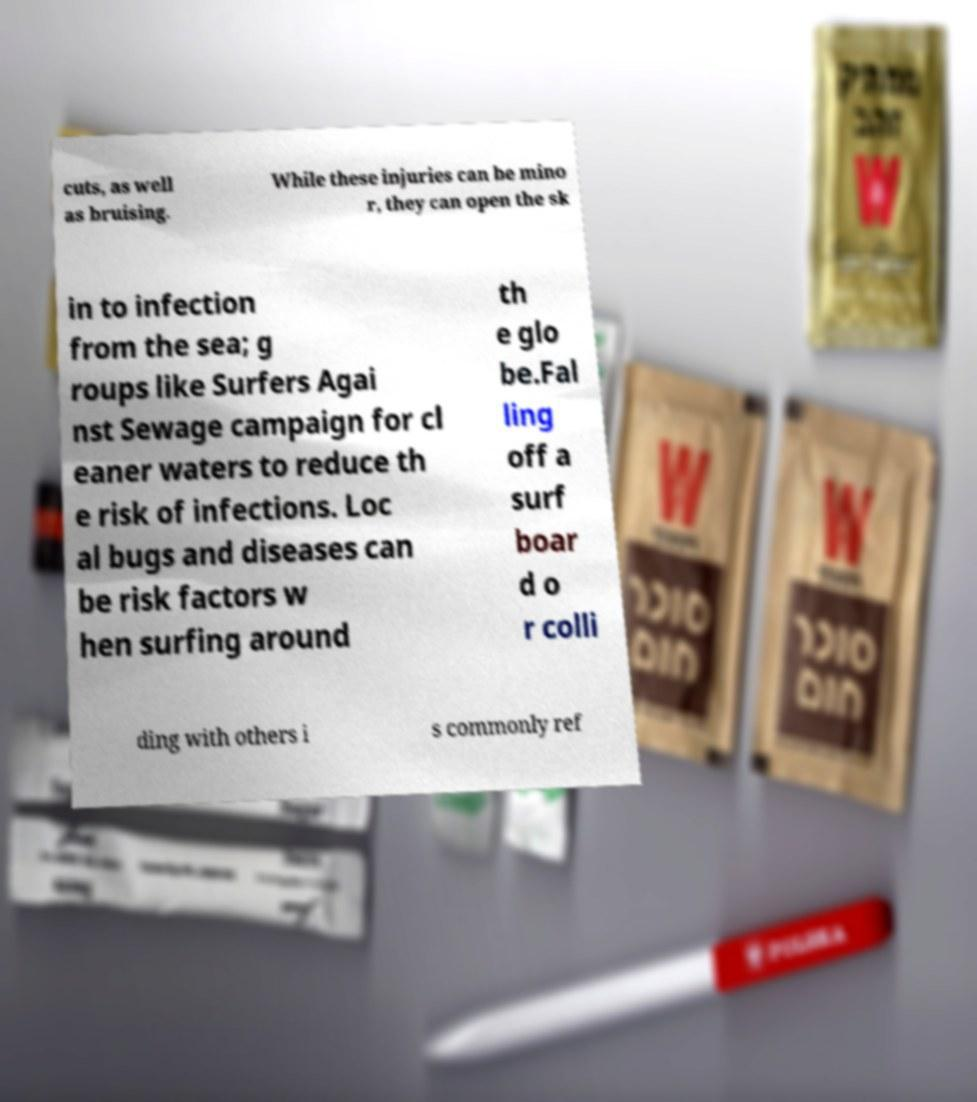For documentation purposes, I need the text within this image transcribed. Could you provide that? cuts, as well as bruising. While these injuries can be mino r, they can open the sk in to infection from the sea; g roups like Surfers Agai nst Sewage campaign for cl eaner waters to reduce th e risk of infections. Loc al bugs and diseases can be risk factors w hen surfing around th e glo be.Fal ling off a surf boar d o r colli ding with others i s commonly ref 